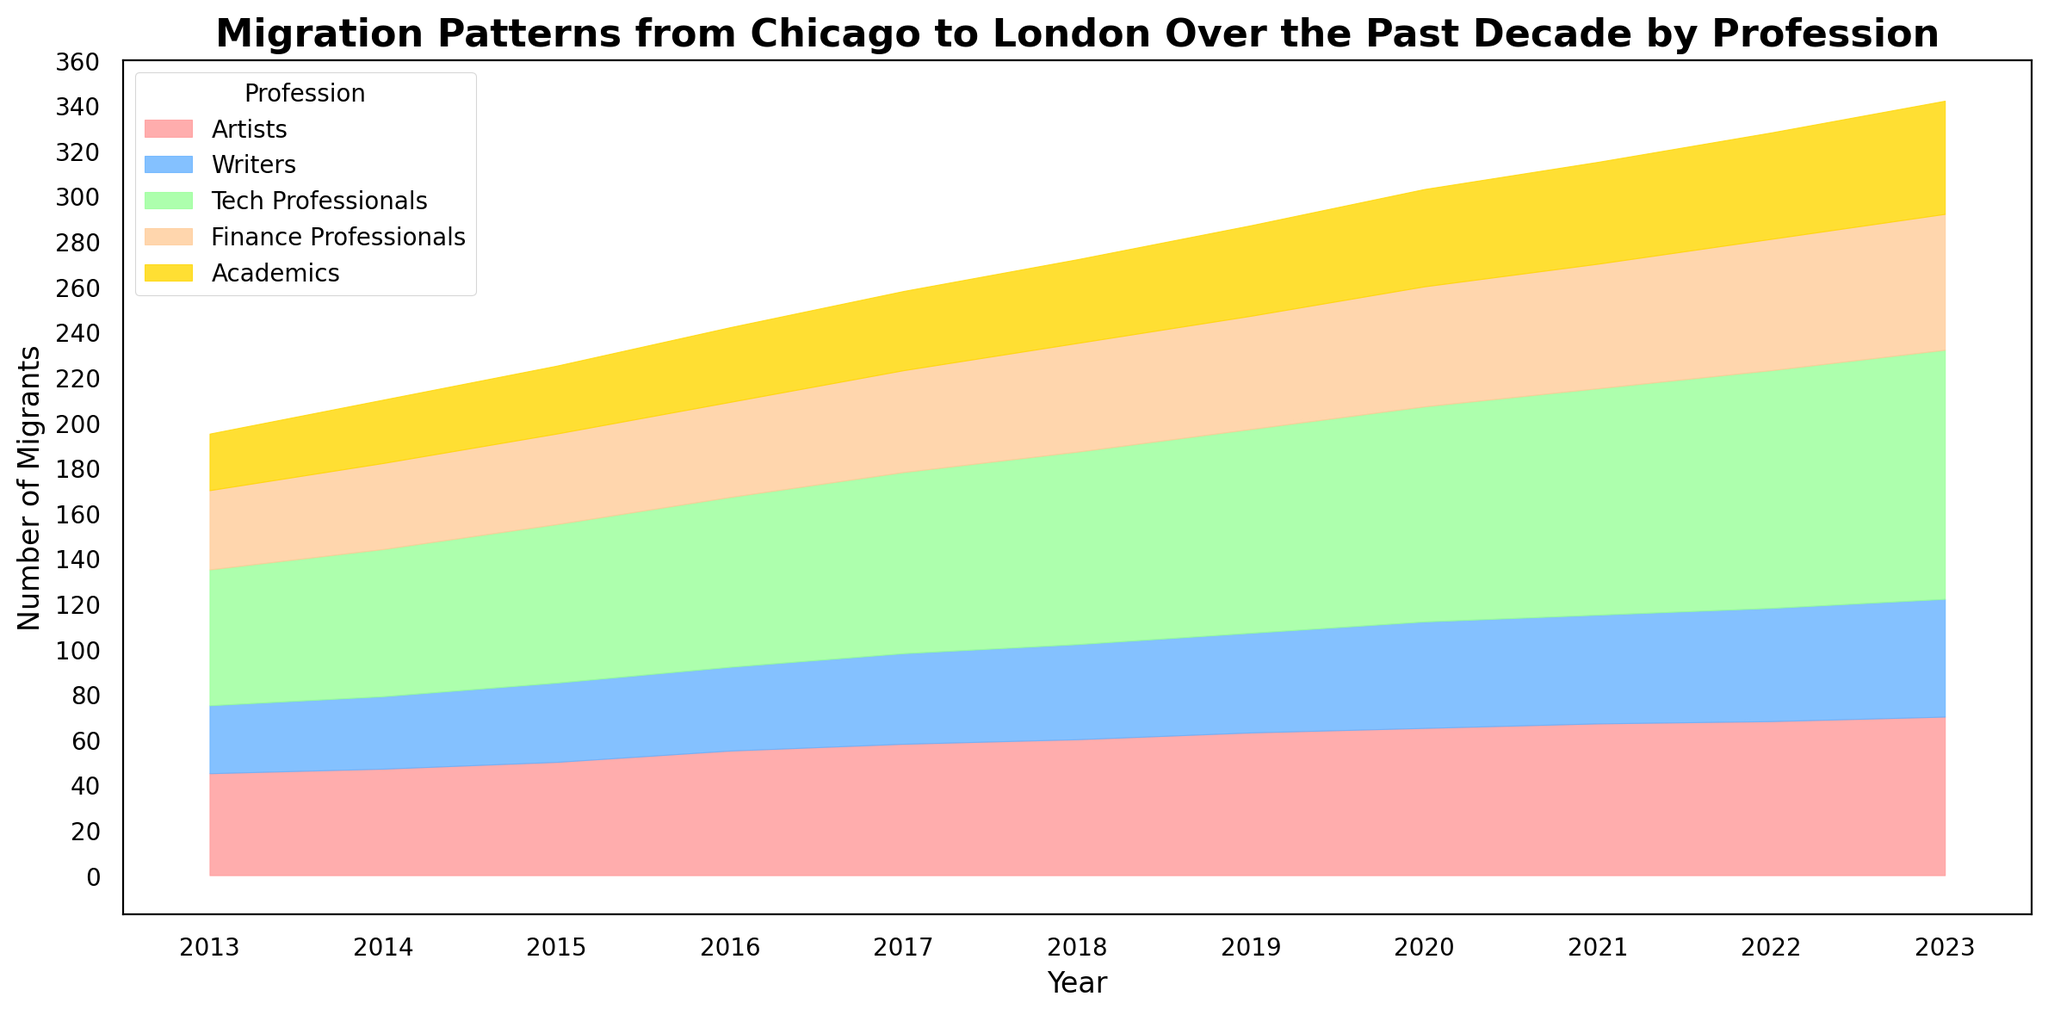Which profession has the highest number of migrants in 2020? Look at the height of the areas for 2020. The tallest area represents the highest number of migrants. The green area, representing Tech Professionals, is the highest.
Answer: Tech Professionals How many total migrants moved to London from Chicago in 2019 across all professions? Sum the heights of all areas for the year 2019. Adding up the values: 63 (Artists) + 44 (Writers) + 90 (Tech Professionals) + 50 (Finance Professionals) + 40 (Academics) equals 287.
Answer: 287 Which profession shows the largest increase in migration from 2013 to 2023? Compare the height of each area in 2023 with its corresponding height in 2013. The green area (Tech Professionals) shows the most significant increase.
Answer: Tech Professionals What is the trend for Artists over the decade? Observe the height of the red area across all years. The height consistently increases from 45 in 2013 to 70 in 2023, indicating an upward trend.
Answer: Increasing trend In 2022, are there more Finance Professionals or Academics migrating to London? Compare the heights of the orange area (Finance Professionals) and the gold area (Academics) in 2022. The orange area is taller.
Answer: Finance Professionals By how much did the number of Tech Professionals migrating in 2016 exceed the number of Writers migrating in the same year? Subtract the number of Writers (37) from the number of Tech Professionals (75) in 2016. The difference is 75 - 37 = 38.
Answer: 38 What proportion of the total migrants in 2021 were Academics? First, find the total migrants in 2021 by summing all numbers: 67 (Artists) + 48 (Writers) + 100 (Tech Professionals) + 55 (Finance Professionals) + 45 (Academics) = 315. The proportion of Academics is 45 / 315 ≈ 0.143.
Answer: Approximately 0.143 Which year saw the most significant increase in the number of Tech Professionals compared to the previous year? Examine the green area and measure the change in height for each year compared to the previous year. The increase from 2021 (100) to 2022 (105) is 5, which is smaller than the increase from 2018 (85) to 2019 (90), which is 5. Going back further, the increase from 2013 (60) to 2014 (65) is 5. Analyzing all, the sharpest increase occurred between 2022 to 2023 since the migration increased from 105 to 110 (5).
Answer: None, all increases are similar (5) What's the average number of Academics migrating annually between 2013 and 2023? Sum the number of Academics migrating each year from 2013 to 2023, then divide by the total number of years (11). The total is 25 + 28 + 30 + 33 + 35 + 37 + 40 + 43 + 45 + 47 + 50 = 413. The average is 413 / 11 ≈ 37.55.
Answer: Approximately 37.55 